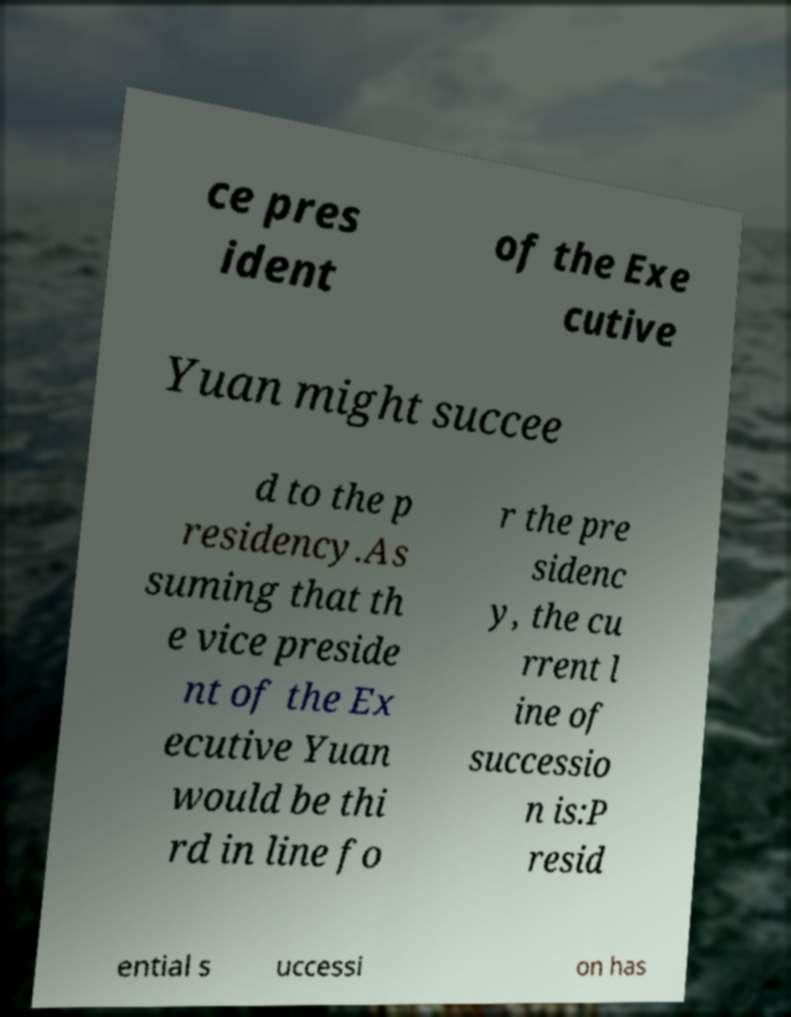Please read and relay the text visible in this image. What does it say? ce pres ident of the Exe cutive Yuan might succee d to the p residency.As suming that th e vice preside nt of the Ex ecutive Yuan would be thi rd in line fo r the pre sidenc y, the cu rrent l ine of successio n is:P resid ential s uccessi on has 